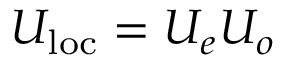Convert formula to latex. <formula><loc_0><loc_0><loc_500><loc_500>U _ { l o c } = U _ { e } U _ { o }</formula> 